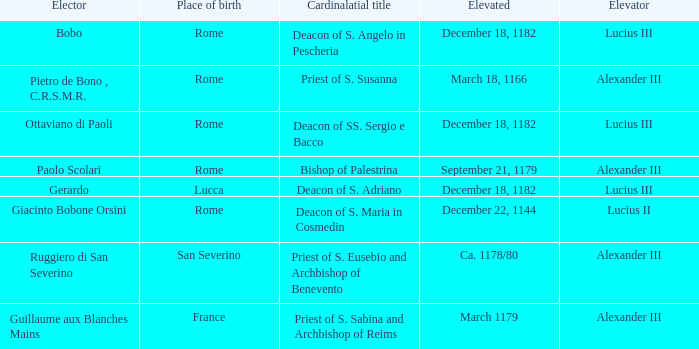Who is the Elector with a Cardinalatial title of Priest of S. Sabina and Archbishop of Reims? Guillaume aux Blanches Mains. 